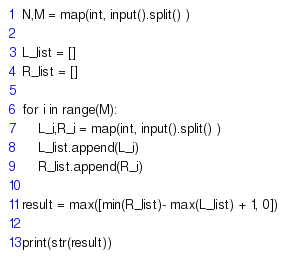Convert code to text. <code><loc_0><loc_0><loc_500><loc_500><_Python_>N,M = map(int, input().split() )

L_list = []
R_list = []

for i in range(M):
    L_i,R_i = map(int, input().split() )
    L_list.append(L_i)
    R_list.append(R_i)

result = max([min(R_list)- max(L_list) + 1, 0])

print(str(result))</code> 